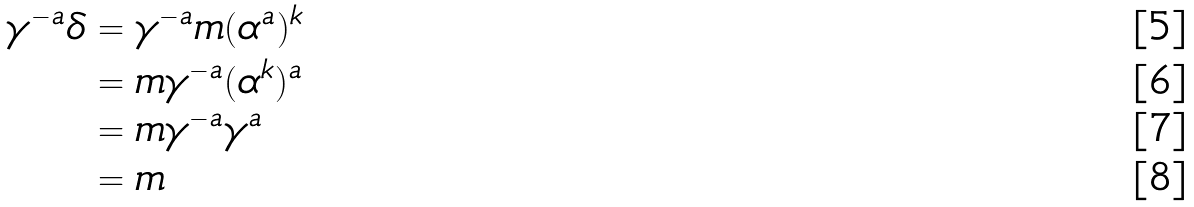Convert formula to latex. <formula><loc_0><loc_0><loc_500><loc_500>\gamma ^ { - a } \delta & = \gamma ^ { - a } m ( \alpha ^ { a } ) ^ { k } \\ & = m \gamma ^ { - a } ( \alpha ^ { k } ) ^ { a } \\ & = m \gamma ^ { - a } \gamma ^ { a } \\ & = m</formula> 